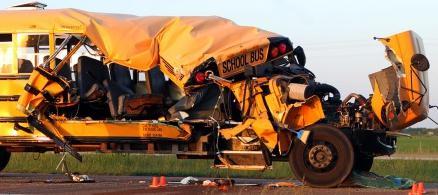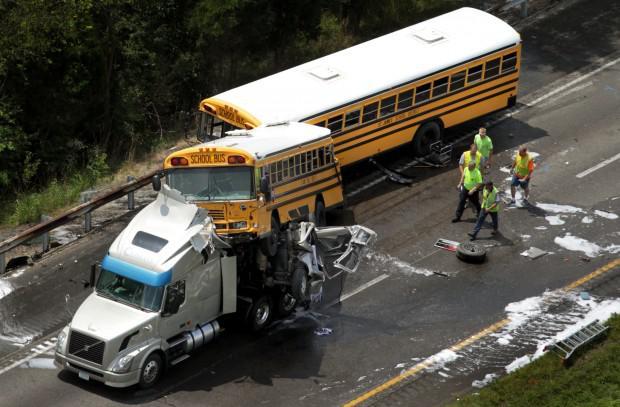The first image is the image on the left, the second image is the image on the right. For the images shown, is this caption "The right image shows a large tow-truck with a flat-fronted bus tilted behind it and overlapping another bus, on a road with white foam on it." true? Answer yes or no. Yes. 